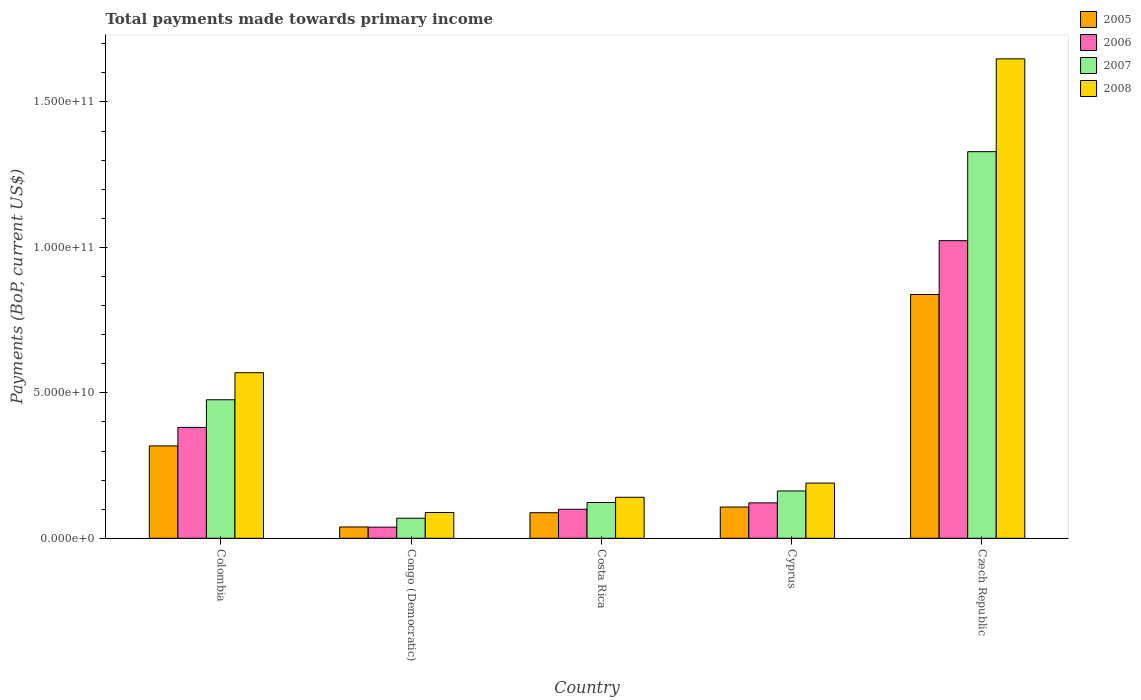How many groups of bars are there?
Offer a very short reply. 5. Are the number of bars on each tick of the X-axis equal?
Make the answer very short. Yes. How many bars are there on the 1st tick from the right?
Provide a succinct answer. 4. What is the total payments made towards primary income in 2008 in Cyprus?
Keep it short and to the point. 1.90e+1. Across all countries, what is the maximum total payments made towards primary income in 2007?
Offer a very short reply. 1.33e+11. Across all countries, what is the minimum total payments made towards primary income in 2005?
Give a very brief answer. 3.89e+09. In which country was the total payments made towards primary income in 2005 maximum?
Keep it short and to the point. Czech Republic. In which country was the total payments made towards primary income in 2007 minimum?
Your answer should be compact. Congo (Democratic). What is the total total payments made towards primary income in 2007 in the graph?
Offer a terse response. 2.16e+11. What is the difference between the total payments made towards primary income in 2005 in Colombia and that in Congo (Democratic)?
Offer a very short reply. 2.79e+1. What is the difference between the total payments made towards primary income in 2007 in Cyprus and the total payments made towards primary income in 2005 in Colombia?
Provide a succinct answer. -1.55e+1. What is the average total payments made towards primary income in 2005 per country?
Provide a succinct answer. 2.78e+1. What is the difference between the total payments made towards primary income of/in 2006 and total payments made towards primary income of/in 2005 in Czech Republic?
Provide a short and direct response. 1.85e+1. What is the ratio of the total payments made towards primary income in 2005 in Costa Rica to that in Cyprus?
Your answer should be very brief. 0.82. What is the difference between the highest and the second highest total payments made towards primary income in 2007?
Make the answer very short. -8.53e+1. What is the difference between the highest and the lowest total payments made towards primary income in 2008?
Give a very brief answer. 1.56e+11. How many bars are there?
Keep it short and to the point. 20. Are all the bars in the graph horizontal?
Give a very brief answer. No. How many countries are there in the graph?
Offer a terse response. 5. Are the values on the major ticks of Y-axis written in scientific E-notation?
Offer a very short reply. Yes. Where does the legend appear in the graph?
Provide a short and direct response. Top right. How many legend labels are there?
Make the answer very short. 4. How are the legend labels stacked?
Provide a succinct answer. Vertical. What is the title of the graph?
Your response must be concise. Total payments made towards primary income. Does "2007" appear as one of the legend labels in the graph?
Your answer should be compact. Yes. What is the label or title of the X-axis?
Your answer should be very brief. Country. What is the label or title of the Y-axis?
Offer a very short reply. Payments (BoP, current US$). What is the Payments (BoP, current US$) of 2005 in Colombia?
Provide a short and direct response. 3.18e+1. What is the Payments (BoP, current US$) of 2006 in Colombia?
Ensure brevity in your answer.  3.81e+1. What is the Payments (BoP, current US$) of 2007 in Colombia?
Offer a terse response. 4.76e+1. What is the Payments (BoP, current US$) of 2008 in Colombia?
Provide a short and direct response. 5.69e+1. What is the Payments (BoP, current US$) in 2005 in Congo (Democratic)?
Give a very brief answer. 3.89e+09. What is the Payments (BoP, current US$) of 2006 in Congo (Democratic)?
Provide a succinct answer. 3.83e+09. What is the Payments (BoP, current US$) of 2007 in Congo (Democratic)?
Your answer should be very brief. 6.90e+09. What is the Payments (BoP, current US$) in 2008 in Congo (Democratic)?
Keep it short and to the point. 8.86e+09. What is the Payments (BoP, current US$) in 2005 in Costa Rica?
Offer a terse response. 8.79e+09. What is the Payments (BoP, current US$) of 2006 in Costa Rica?
Provide a succinct answer. 9.98e+09. What is the Payments (BoP, current US$) of 2007 in Costa Rica?
Ensure brevity in your answer.  1.23e+1. What is the Payments (BoP, current US$) of 2008 in Costa Rica?
Your response must be concise. 1.41e+1. What is the Payments (BoP, current US$) in 2005 in Cyprus?
Ensure brevity in your answer.  1.07e+1. What is the Payments (BoP, current US$) of 2006 in Cyprus?
Your answer should be very brief. 1.22e+1. What is the Payments (BoP, current US$) in 2007 in Cyprus?
Keep it short and to the point. 1.63e+1. What is the Payments (BoP, current US$) of 2008 in Cyprus?
Give a very brief answer. 1.90e+1. What is the Payments (BoP, current US$) in 2005 in Czech Republic?
Offer a very short reply. 8.38e+1. What is the Payments (BoP, current US$) in 2006 in Czech Republic?
Offer a terse response. 1.02e+11. What is the Payments (BoP, current US$) of 2007 in Czech Republic?
Your response must be concise. 1.33e+11. What is the Payments (BoP, current US$) in 2008 in Czech Republic?
Your answer should be compact. 1.65e+11. Across all countries, what is the maximum Payments (BoP, current US$) of 2005?
Keep it short and to the point. 8.38e+1. Across all countries, what is the maximum Payments (BoP, current US$) of 2006?
Your answer should be compact. 1.02e+11. Across all countries, what is the maximum Payments (BoP, current US$) in 2007?
Your response must be concise. 1.33e+11. Across all countries, what is the maximum Payments (BoP, current US$) in 2008?
Give a very brief answer. 1.65e+11. Across all countries, what is the minimum Payments (BoP, current US$) of 2005?
Offer a terse response. 3.89e+09. Across all countries, what is the minimum Payments (BoP, current US$) in 2006?
Provide a succinct answer. 3.83e+09. Across all countries, what is the minimum Payments (BoP, current US$) of 2007?
Provide a short and direct response. 6.90e+09. Across all countries, what is the minimum Payments (BoP, current US$) in 2008?
Offer a very short reply. 8.86e+09. What is the total Payments (BoP, current US$) in 2005 in the graph?
Your response must be concise. 1.39e+11. What is the total Payments (BoP, current US$) in 2006 in the graph?
Offer a terse response. 1.66e+11. What is the total Payments (BoP, current US$) in 2007 in the graph?
Your response must be concise. 2.16e+11. What is the total Payments (BoP, current US$) in 2008 in the graph?
Provide a succinct answer. 2.64e+11. What is the difference between the Payments (BoP, current US$) in 2005 in Colombia and that in Congo (Democratic)?
Provide a short and direct response. 2.79e+1. What is the difference between the Payments (BoP, current US$) in 2006 in Colombia and that in Congo (Democratic)?
Ensure brevity in your answer.  3.43e+1. What is the difference between the Payments (BoP, current US$) in 2007 in Colombia and that in Congo (Democratic)?
Provide a short and direct response. 4.07e+1. What is the difference between the Payments (BoP, current US$) of 2008 in Colombia and that in Congo (Democratic)?
Ensure brevity in your answer.  4.81e+1. What is the difference between the Payments (BoP, current US$) of 2005 in Colombia and that in Costa Rica?
Keep it short and to the point. 2.30e+1. What is the difference between the Payments (BoP, current US$) in 2006 in Colombia and that in Costa Rica?
Your response must be concise. 2.81e+1. What is the difference between the Payments (BoP, current US$) in 2007 in Colombia and that in Costa Rica?
Make the answer very short. 3.53e+1. What is the difference between the Payments (BoP, current US$) of 2008 in Colombia and that in Costa Rica?
Provide a short and direct response. 4.28e+1. What is the difference between the Payments (BoP, current US$) in 2005 in Colombia and that in Cyprus?
Your answer should be very brief. 2.10e+1. What is the difference between the Payments (BoP, current US$) in 2006 in Colombia and that in Cyprus?
Provide a short and direct response. 2.59e+1. What is the difference between the Payments (BoP, current US$) of 2007 in Colombia and that in Cyprus?
Provide a succinct answer. 3.14e+1. What is the difference between the Payments (BoP, current US$) of 2008 in Colombia and that in Cyprus?
Ensure brevity in your answer.  3.80e+1. What is the difference between the Payments (BoP, current US$) of 2005 in Colombia and that in Czech Republic?
Give a very brief answer. -5.21e+1. What is the difference between the Payments (BoP, current US$) in 2006 in Colombia and that in Czech Republic?
Provide a short and direct response. -6.42e+1. What is the difference between the Payments (BoP, current US$) of 2007 in Colombia and that in Czech Republic?
Your answer should be very brief. -8.53e+1. What is the difference between the Payments (BoP, current US$) of 2008 in Colombia and that in Czech Republic?
Your response must be concise. -1.08e+11. What is the difference between the Payments (BoP, current US$) of 2005 in Congo (Democratic) and that in Costa Rica?
Make the answer very short. -4.89e+09. What is the difference between the Payments (BoP, current US$) in 2006 in Congo (Democratic) and that in Costa Rica?
Make the answer very short. -6.15e+09. What is the difference between the Payments (BoP, current US$) in 2007 in Congo (Democratic) and that in Costa Rica?
Ensure brevity in your answer.  -5.40e+09. What is the difference between the Payments (BoP, current US$) of 2008 in Congo (Democratic) and that in Costa Rica?
Offer a very short reply. -5.23e+09. What is the difference between the Payments (BoP, current US$) of 2005 in Congo (Democratic) and that in Cyprus?
Give a very brief answer. -6.85e+09. What is the difference between the Payments (BoP, current US$) of 2006 in Congo (Democratic) and that in Cyprus?
Give a very brief answer. -8.35e+09. What is the difference between the Payments (BoP, current US$) in 2007 in Congo (Democratic) and that in Cyprus?
Offer a very short reply. -9.37e+09. What is the difference between the Payments (BoP, current US$) of 2008 in Congo (Democratic) and that in Cyprus?
Give a very brief answer. -1.01e+1. What is the difference between the Payments (BoP, current US$) in 2005 in Congo (Democratic) and that in Czech Republic?
Your response must be concise. -7.99e+1. What is the difference between the Payments (BoP, current US$) in 2006 in Congo (Democratic) and that in Czech Republic?
Keep it short and to the point. -9.85e+1. What is the difference between the Payments (BoP, current US$) of 2007 in Congo (Democratic) and that in Czech Republic?
Provide a short and direct response. -1.26e+11. What is the difference between the Payments (BoP, current US$) of 2008 in Congo (Democratic) and that in Czech Republic?
Make the answer very short. -1.56e+11. What is the difference between the Payments (BoP, current US$) in 2005 in Costa Rica and that in Cyprus?
Offer a terse response. -1.96e+09. What is the difference between the Payments (BoP, current US$) in 2006 in Costa Rica and that in Cyprus?
Your answer should be very brief. -2.20e+09. What is the difference between the Payments (BoP, current US$) in 2007 in Costa Rica and that in Cyprus?
Your answer should be compact. -3.97e+09. What is the difference between the Payments (BoP, current US$) of 2008 in Costa Rica and that in Cyprus?
Offer a terse response. -4.88e+09. What is the difference between the Payments (BoP, current US$) of 2005 in Costa Rica and that in Czech Republic?
Keep it short and to the point. -7.50e+1. What is the difference between the Payments (BoP, current US$) of 2006 in Costa Rica and that in Czech Republic?
Your answer should be compact. -9.23e+1. What is the difference between the Payments (BoP, current US$) of 2007 in Costa Rica and that in Czech Republic?
Provide a succinct answer. -1.21e+11. What is the difference between the Payments (BoP, current US$) of 2008 in Costa Rica and that in Czech Republic?
Offer a terse response. -1.51e+11. What is the difference between the Payments (BoP, current US$) of 2005 in Cyprus and that in Czech Republic?
Your answer should be compact. -7.31e+1. What is the difference between the Payments (BoP, current US$) in 2006 in Cyprus and that in Czech Republic?
Keep it short and to the point. -9.01e+1. What is the difference between the Payments (BoP, current US$) of 2007 in Cyprus and that in Czech Republic?
Make the answer very short. -1.17e+11. What is the difference between the Payments (BoP, current US$) of 2008 in Cyprus and that in Czech Republic?
Provide a succinct answer. -1.46e+11. What is the difference between the Payments (BoP, current US$) of 2005 in Colombia and the Payments (BoP, current US$) of 2006 in Congo (Democratic)?
Make the answer very short. 2.79e+1. What is the difference between the Payments (BoP, current US$) of 2005 in Colombia and the Payments (BoP, current US$) of 2007 in Congo (Democratic)?
Your response must be concise. 2.49e+1. What is the difference between the Payments (BoP, current US$) of 2005 in Colombia and the Payments (BoP, current US$) of 2008 in Congo (Democratic)?
Make the answer very short. 2.29e+1. What is the difference between the Payments (BoP, current US$) of 2006 in Colombia and the Payments (BoP, current US$) of 2007 in Congo (Democratic)?
Provide a succinct answer. 3.12e+1. What is the difference between the Payments (BoP, current US$) in 2006 in Colombia and the Payments (BoP, current US$) in 2008 in Congo (Democratic)?
Your response must be concise. 2.93e+1. What is the difference between the Payments (BoP, current US$) in 2007 in Colombia and the Payments (BoP, current US$) in 2008 in Congo (Democratic)?
Give a very brief answer. 3.88e+1. What is the difference between the Payments (BoP, current US$) in 2005 in Colombia and the Payments (BoP, current US$) in 2006 in Costa Rica?
Make the answer very short. 2.18e+1. What is the difference between the Payments (BoP, current US$) of 2005 in Colombia and the Payments (BoP, current US$) of 2007 in Costa Rica?
Make the answer very short. 1.95e+1. What is the difference between the Payments (BoP, current US$) in 2005 in Colombia and the Payments (BoP, current US$) in 2008 in Costa Rica?
Provide a short and direct response. 1.77e+1. What is the difference between the Payments (BoP, current US$) in 2006 in Colombia and the Payments (BoP, current US$) in 2007 in Costa Rica?
Ensure brevity in your answer.  2.58e+1. What is the difference between the Payments (BoP, current US$) in 2006 in Colombia and the Payments (BoP, current US$) in 2008 in Costa Rica?
Your response must be concise. 2.40e+1. What is the difference between the Payments (BoP, current US$) in 2007 in Colombia and the Payments (BoP, current US$) in 2008 in Costa Rica?
Keep it short and to the point. 3.35e+1. What is the difference between the Payments (BoP, current US$) in 2005 in Colombia and the Payments (BoP, current US$) in 2006 in Cyprus?
Provide a short and direct response. 1.96e+1. What is the difference between the Payments (BoP, current US$) in 2005 in Colombia and the Payments (BoP, current US$) in 2007 in Cyprus?
Make the answer very short. 1.55e+1. What is the difference between the Payments (BoP, current US$) in 2005 in Colombia and the Payments (BoP, current US$) in 2008 in Cyprus?
Your response must be concise. 1.28e+1. What is the difference between the Payments (BoP, current US$) in 2006 in Colombia and the Payments (BoP, current US$) in 2007 in Cyprus?
Offer a very short reply. 2.19e+1. What is the difference between the Payments (BoP, current US$) of 2006 in Colombia and the Payments (BoP, current US$) of 2008 in Cyprus?
Your answer should be very brief. 1.91e+1. What is the difference between the Payments (BoP, current US$) in 2007 in Colombia and the Payments (BoP, current US$) in 2008 in Cyprus?
Your answer should be compact. 2.87e+1. What is the difference between the Payments (BoP, current US$) in 2005 in Colombia and the Payments (BoP, current US$) in 2006 in Czech Republic?
Give a very brief answer. -7.06e+1. What is the difference between the Payments (BoP, current US$) in 2005 in Colombia and the Payments (BoP, current US$) in 2007 in Czech Republic?
Give a very brief answer. -1.01e+11. What is the difference between the Payments (BoP, current US$) of 2005 in Colombia and the Payments (BoP, current US$) of 2008 in Czech Republic?
Provide a succinct answer. -1.33e+11. What is the difference between the Payments (BoP, current US$) in 2006 in Colombia and the Payments (BoP, current US$) in 2007 in Czech Republic?
Your answer should be very brief. -9.48e+1. What is the difference between the Payments (BoP, current US$) in 2006 in Colombia and the Payments (BoP, current US$) in 2008 in Czech Republic?
Provide a succinct answer. -1.27e+11. What is the difference between the Payments (BoP, current US$) of 2007 in Colombia and the Payments (BoP, current US$) of 2008 in Czech Republic?
Offer a very short reply. -1.17e+11. What is the difference between the Payments (BoP, current US$) in 2005 in Congo (Democratic) and the Payments (BoP, current US$) in 2006 in Costa Rica?
Make the answer very short. -6.08e+09. What is the difference between the Payments (BoP, current US$) of 2005 in Congo (Democratic) and the Payments (BoP, current US$) of 2007 in Costa Rica?
Give a very brief answer. -8.41e+09. What is the difference between the Payments (BoP, current US$) in 2005 in Congo (Democratic) and the Payments (BoP, current US$) in 2008 in Costa Rica?
Keep it short and to the point. -1.02e+1. What is the difference between the Payments (BoP, current US$) of 2006 in Congo (Democratic) and the Payments (BoP, current US$) of 2007 in Costa Rica?
Your answer should be compact. -8.47e+09. What is the difference between the Payments (BoP, current US$) in 2006 in Congo (Democratic) and the Payments (BoP, current US$) in 2008 in Costa Rica?
Provide a succinct answer. -1.03e+1. What is the difference between the Payments (BoP, current US$) in 2007 in Congo (Democratic) and the Payments (BoP, current US$) in 2008 in Costa Rica?
Give a very brief answer. -7.19e+09. What is the difference between the Payments (BoP, current US$) of 2005 in Congo (Democratic) and the Payments (BoP, current US$) of 2006 in Cyprus?
Your answer should be compact. -8.29e+09. What is the difference between the Payments (BoP, current US$) in 2005 in Congo (Democratic) and the Payments (BoP, current US$) in 2007 in Cyprus?
Your answer should be very brief. -1.24e+1. What is the difference between the Payments (BoP, current US$) of 2005 in Congo (Democratic) and the Payments (BoP, current US$) of 2008 in Cyprus?
Offer a very short reply. -1.51e+1. What is the difference between the Payments (BoP, current US$) of 2006 in Congo (Democratic) and the Payments (BoP, current US$) of 2007 in Cyprus?
Keep it short and to the point. -1.24e+1. What is the difference between the Payments (BoP, current US$) of 2006 in Congo (Democratic) and the Payments (BoP, current US$) of 2008 in Cyprus?
Make the answer very short. -1.51e+1. What is the difference between the Payments (BoP, current US$) in 2007 in Congo (Democratic) and the Payments (BoP, current US$) in 2008 in Cyprus?
Offer a very short reply. -1.21e+1. What is the difference between the Payments (BoP, current US$) of 2005 in Congo (Democratic) and the Payments (BoP, current US$) of 2006 in Czech Republic?
Offer a very short reply. -9.84e+1. What is the difference between the Payments (BoP, current US$) of 2005 in Congo (Democratic) and the Payments (BoP, current US$) of 2007 in Czech Republic?
Give a very brief answer. -1.29e+11. What is the difference between the Payments (BoP, current US$) of 2005 in Congo (Democratic) and the Payments (BoP, current US$) of 2008 in Czech Republic?
Your answer should be very brief. -1.61e+11. What is the difference between the Payments (BoP, current US$) in 2006 in Congo (Democratic) and the Payments (BoP, current US$) in 2007 in Czech Republic?
Your answer should be compact. -1.29e+11. What is the difference between the Payments (BoP, current US$) of 2006 in Congo (Democratic) and the Payments (BoP, current US$) of 2008 in Czech Republic?
Your answer should be very brief. -1.61e+11. What is the difference between the Payments (BoP, current US$) in 2007 in Congo (Democratic) and the Payments (BoP, current US$) in 2008 in Czech Republic?
Provide a succinct answer. -1.58e+11. What is the difference between the Payments (BoP, current US$) of 2005 in Costa Rica and the Payments (BoP, current US$) of 2006 in Cyprus?
Provide a succinct answer. -3.39e+09. What is the difference between the Payments (BoP, current US$) in 2005 in Costa Rica and the Payments (BoP, current US$) in 2007 in Cyprus?
Make the answer very short. -7.48e+09. What is the difference between the Payments (BoP, current US$) of 2005 in Costa Rica and the Payments (BoP, current US$) of 2008 in Cyprus?
Keep it short and to the point. -1.02e+1. What is the difference between the Payments (BoP, current US$) in 2006 in Costa Rica and the Payments (BoP, current US$) in 2007 in Cyprus?
Make the answer very short. -6.29e+09. What is the difference between the Payments (BoP, current US$) in 2006 in Costa Rica and the Payments (BoP, current US$) in 2008 in Cyprus?
Give a very brief answer. -8.99e+09. What is the difference between the Payments (BoP, current US$) of 2007 in Costa Rica and the Payments (BoP, current US$) of 2008 in Cyprus?
Keep it short and to the point. -6.67e+09. What is the difference between the Payments (BoP, current US$) of 2005 in Costa Rica and the Payments (BoP, current US$) of 2006 in Czech Republic?
Offer a very short reply. -9.35e+1. What is the difference between the Payments (BoP, current US$) of 2005 in Costa Rica and the Payments (BoP, current US$) of 2007 in Czech Republic?
Offer a very short reply. -1.24e+11. What is the difference between the Payments (BoP, current US$) in 2005 in Costa Rica and the Payments (BoP, current US$) in 2008 in Czech Republic?
Make the answer very short. -1.56e+11. What is the difference between the Payments (BoP, current US$) in 2006 in Costa Rica and the Payments (BoP, current US$) in 2007 in Czech Republic?
Provide a short and direct response. -1.23e+11. What is the difference between the Payments (BoP, current US$) of 2006 in Costa Rica and the Payments (BoP, current US$) of 2008 in Czech Republic?
Your answer should be compact. -1.55e+11. What is the difference between the Payments (BoP, current US$) of 2007 in Costa Rica and the Payments (BoP, current US$) of 2008 in Czech Republic?
Offer a very short reply. -1.53e+11. What is the difference between the Payments (BoP, current US$) in 2005 in Cyprus and the Payments (BoP, current US$) in 2006 in Czech Republic?
Make the answer very short. -9.16e+1. What is the difference between the Payments (BoP, current US$) in 2005 in Cyprus and the Payments (BoP, current US$) in 2007 in Czech Republic?
Your response must be concise. -1.22e+11. What is the difference between the Payments (BoP, current US$) of 2005 in Cyprus and the Payments (BoP, current US$) of 2008 in Czech Republic?
Keep it short and to the point. -1.54e+11. What is the difference between the Payments (BoP, current US$) of 2006 in Cyprus and the Payments (BoP, current US$) of 2007 in Czech Republic?
Ensure brevity in your answer.  -1.21e+11. What is the difference between the Payments (BoP, current US$) of 2006 in Cyprus and the Payments (BoP, current US$) of 2008 in Czech Republic?
Your answer should be very brief. -1.53e+11. What is the difference between the Payments (BoP, current US$) of 2007 in Cyprus and the Payments (BoP, current US$) of 2008 in Czech Republic?
Keep it short and to the point. -1.49e+11. What is the average Payments (BoP, current US$) in 2005 per country?
Make the answer very short. 2.78e+1. What is the average Payments (BoP, current US$) in 2006 per country?
Your answer should be compact. 3.33e+1. What is the average Payments (BoP, current US$) in 2007 per country?
Provide a short and direct response. 4.32e+1. What is the average Payments (BoP, current US$) in 2008 per country?
Offer a very short reply. 5.27e+1. What is the difference between the Payments (BoP, current US$) of 2005 and Payments (BoP, current US$) of 2006 in Colombia?
Your answer should be very brief. -6.36e+09. What is the difference between the Payments (BoP, current US$) in 2005 and Payments (BoP, current US$) in 2007 in Colombia?
Ensure brevity in your answer.  -1.59e+1. What is the difference between the Payments (BoP, current US$) in 2005 and Payments (BoP, current US$) in 2008 in Colombia?
Make the answer very short. -2.52e+1. What is the difference between the Payments (BoP, current US$) in 2006 and Payments (BoP, current US$) in 2007 in Colombia?
Offer a very short reply. -9.51e+09. What is the difference between the Payments (BoP, current US$) of 2006 and Payments (BoP, current US$) of 2008 in Colombia?
Provide a short and direct response. -1.88e+1. What is the difference between the Payments (BoP, current US$) in 2007 and Payments (BoP, current US$) in 2008 in Colombia?
Offer a very short reply. -9.30e+09. What is the difference between the Payments (BoP, current US$) in 2005 and Payments (BoP, current US$) in 2006 in Congo (Democratic)?
Keep it short and to the point. 6.30e+07. What is the difference between the Payments (BoP, current US$) of 2005 and Payments (BoP, current US$) of 2007 in Congo (Democratic)?
Provide a short and direct response. -3.01e+09. What is the difference between the Payments (BoP, current US$) of 2005 and Payments (BoP, current US$) of 2008 in Congo (Democratic)?
Your response must be concise. -4.97e+09. What is the difference between the Payments (BoP, current US$) in 2006 and Payments (BoP, current US$) in 2007 in Congo (Democratic)?
Make the answer very short. -3.07e+09. What is the difference between the Payments (BoP, current US$) of 2006 and Payments (BoP, current US$) of 2008 in Congo (Democratic)?
Your response must be concise. -5.03e+09. What is the difference between the Payments (BoP, current US$) of 2007 and Payments (BoP, current US$) of 2008 in Congo (Democratic)?
Offer a very short reply. -1.96e+09. What is the difference between the Payments (BoP, current US$) in 2005 and Payments (BoP, current US$) in 2006 in Costa Rica?
Your answer should be very brief. -1.19e+09. What is the difference between the Payments (BoP, current US$) in 2005 and Payments (BoP, current US$) in 2007 in Costa Rica?
Your answer should be compact. -3.51e+09. What is the difference between the Payments (BoP, current US$) in 2005 and Payments (BoP, current US$) in 2008 in Costa Rica?
Your response must be concise. -5.31e+09. What is the difference between the Payments (BoP, current US$) of 2006 and Payments (BoP, current US$) of 2007 in Costa Rica?
Provide a short and direct response. -2.32e+09. What is the difference between the Payments (BoP, current US$) in 2006 and Payments (BoP, current US$) in 2008 in Costa Rica?
Give a very brief answer. -4.12e+09. What is the difference between the Payments (BoP, current US$) of 2007 and Payments (BoP, current US$) of 2008 in Costa Rica?
Your answer should be compact. -1.79e+09. What is the difference between the Payments (BoP, current US$) of 2005 and Payments (BoP, current US$) of 2006 in Cyprus?
Make the answer very short. -1.43e+09. What is the difference between the Payments (BoP, current US$) in 2005 and Payments (BoP, current US$) in 2007 in Cyprus?
Keep it short and to the point. -5.52e+09. What is the difference between the Payments (BoP, current US$) of 2005 and Payments (BoP, current US$) of 2008 in Cyprus?
Provide a succinct answer. -8.22e+09. What is the difference between the Payments (BoP, current US$) in 2006 and Payments (BoP, current US$) in 2007 in Cyprus?
Offer a terse response. -4.09e+09. What is the difference between the Payments (BoP, current US$) in 2006 and Payments (BoP, current US$) in 2008 in Cyprus?
Give a very brief answer. -6.79e+09. What is the difference between the Payments (BoP, current US$) of 2007 and Payments (BoP, current US$) of 2008 in Cyprus?
Provide a short and direct response. -2.70e+09. What is the difference between the Payments (BoP, current US$) in 2005 and Payments (BoP, current US$) in 2006 in Czech Republic?
Offer a terse response. -1.85e+1. What is the difference between the Payments (BoP, current US$) of 2005 and Payments (BoP, current US$) of 2007 in Czech Republic?
Offer a terse response. -4.91e+1. What is the difference between the Payments (BoP, current US$) in 2005 and Payments (BoP, current US$) in 2008 in Czech Republic?
Provide a succinct answer. -8.10e+1. What is the difference between the Payments (BoP, current US$) of 2006 and Payments (BoP, current US$) of 2007 in Czech Republic?
Keep it short and to the point. -3.06e+1. What is the difference between the Payments (BoP, current US$) in 2006 and Payments (BoP, current US$) in 2008 in Czech Republic?
Your answer should be compact. -6.25e+1. What is the difference between the Payments (BoP, current US$) of 2007 and Payments (BoP, current US$) of 2008 in Czech Republic?
Your response must be concise. -3.19e+1. What is the ratio of the Payments (BoP, current US$) of 2005 in Colombia to that in Congo (Democratic)?
Your answer should be very brief. 8.16. What is the ratio of the Payments (BoP, current US$) in 2006 in Colombia to that in Congo (Democratic)?
Keep it short and to the point. 9.96. What is the ratio of the Payments (BoP, current US$) of 2007 in Colombia to that in Congo (Democratic)?
Provide a short and direct response. 6.9. What is the ratio of the Payments (BoP, current US$) of 2008 in Colombia to that in Congo (Democratic)?
Your response must be concise. 6.42. What is the ratio of the Payments (BoP, current US$) in 2005 in Colombia to that in Costa Rica?
Ensure brevity in your answer.  3.61. What is the ratio of the Payments (BoP, current US$) of 2006 in Colombia to that in Costa Rica?
Provide a short and direct response. 3.82. What is the ratio of the Payments (BoP, current US$) in 2007 in Colombia to that in Costa Rica?
Your response must be concise. 3.87. What is the ratio of the Payments (BoP, current US$) in 2008 in Colombia to that in Costa Rica?
Offer a very short reply. 4.04. What is the ratio of the Payments (BoP, current US$) in 2005 in Colombia to that in Cyprus?
Offer a terse response. 2.96. What is the ratio of the Payments (BoP, current US$) of 2006 in Colombia to that in Cyprus?
Provide a succinct answer. 3.13. What is the ratio of the Payments (BoP, current US$) in 2007 in Colombia to that in Cyprus?
Make the answer very short. 2.93. What is the ratio of the Payments (BoP, current US$) of 2008 in Colombia to that in Cyprus?
Give a very brief answer. 3. What is the ratio of the Payments (BoP, current US$) in 2005 in Colombia to that in Czech Republic?
Your answer should be compact. 0.38. What is the ratio of the Payments (BoP, current US$) in 2006 in Colombia to that in Czech Republic?
Provide a short and direct response. 0.37. What is the ratio of the Payments (BoP, current US$) of 2007 in Colombia to that in Czech Republic?
Offer a very short reply. 0.36. What is the ratio of the Payments (BoP, current US$) in 2008 in Colombia to that in Czech Republic?
Provide a succinct answer. 0.35. What is the ratio of the Payments (BoP, current US$) of 2005 in Congo (Democratic) to that in Costa Rica?
Offer a terse response. 0.44. What is the ratio of the Payments (BoP, current US$) of 2006 in Congo (Democratic) to that in Costa Rica?
Make the answer very short. 0.38. What is the ratio of the Payments (BoP, current US$) of 2007 in Congo (Democratic) to that in Costa Rica?
Provide a short and direct response. 0.56. What is the ratio of the Payments (BoP, current US$) in 2008 in Congo (Democratic) to that in Costa Rica?
Make the answer very short. 0.63. What is the ratio of the Payments (BoP, current US$) of 2005 in Congo (Democratic) to that in Cyprus?
Offer a very short reply. 0.36. What is the ratio of the Payments (BoP, current US$) of 2006 in Congo (Democratic) to that in Cyprus?
Provide a succinct answer. 0.31. What is the ratio of the Payments (BoP, current US$) in 2007 in Congo (Democratic) to that in Cyprus?
Make the answer very short. 0.42. What is the ratio of the Payments (BoP, current US$) in 2008 in Congo (Democratic) to that in Cyprus?
Your answer should be very brief. 0.47. What is the ratio of the Payments (BoP, current US$) in 2005 in Congo (Democratic) to that in Czech Republic?
Your response must be concise. 0.05. What is the ratio of the Payments (BoP, current US$) in 2006 in Congo (Democratic) to that in Czech Republic?
Your answer should be compact. 0.04. What is the ratio of the Payments (BoP, current US$) of 2007 in Congo (Democratic) to that in Czech Republic?
Ensure brevity in your answer.  0.05. What is the ratio of the Payments (BoP, current US$) of 2008 in Congo (Democratic) to that in Czech Republic?
Ensure brevity in your answer.  0.05. What is the ratio of the Payments (BoP, current US$) of 2005 in Costa Rica to that in Cyprus?
Give a very brief answer. 0.82. What is the ratio of the Payments (BoP, current US$) of 2006 in Costa Rica to that in Cyprus?
Offer a terse response. 0.82. What is the ratio of the Payments (BoP, current US$) in 2007 in Costa Rica to that in Cyprus?
Offer a very short reply. 0.76. What is the ratio of the Payments (BoP, current US$) in 2008 in Costa Rica to that in Cyprus?
Your answer should be compact. 0.74. What is the ratio of the Payments (BoP, current US$) of 2005 in Costa Rica to that in Czech Republic?
Offer a very short reply. 0.1. What is the ratio of the Payments (BoP, current US$) in 2006 in Costa Rica to that in Czech Republic?
Provide a succinct answer. 0.1. What is the ratio of the Payments (BoP, current US$) of 2007 in Costa Rica to that in Czech Republic?
Your answer should be very brief. 0.09. What is the ratio of the Payments (BoP, current US$) in 2008 in Costa Rica to that in Czech Republic?
Your answer should be compact. 0.09. What is the ratio of the Payments (BoP, current US$) of 2005 in Cyprus to that in Czech Republic?
Give a very brief answer. 0.13. What is the ratio of the Payments (BoP, current US$) of 2006 in Cyprus to that in Czech Republic?
Provide a short and direct response. 0.12. What is the ratio of the Payments (BoP, current US$) of 2007 in Cyprus to that in Czech Republic?
Offer a very short reply. 0.12. What is the ratio of the Payments (BoP, current US$) of 2008 in Cyprus to that in Czech Republic?
Provide a succinct answer. 0.12. What is the difference between the highest and the second highest Payments (BoP, current US$) of 2005?
Your answer should be very brief. 5.21e+1. What is the difference between the highest and the second highest Payments (BoP, current US$) in 2006?
Give a very brief answer. 6.42e+1. What is the difference between the highest and the second highest Payments (BoP, current US$) in 2007?
Offer a terse response. 8.53e+1. What is the difference between the highest and the second highest Payments (BoP, current US$) in 2008?
Keep it short and to the point. 1.08e+11. What is the difference between the highest and the lowest Payments (BoP, current US$) in 2005?
Keep it short and to the point. 7.99e+1. What is the difference between the highest and the lowest Payments (BoP, current US$) of 2006?
Keep it short and to the point. 9.85e+1. What is the difference between the highest and the lowest Payments (BoP, current US$) of 2007?
Offer a terse response. 1.26e+11. What is the difference between the highest and the lowest Payments (BoP, current US$) of 2008?
Give a very brief answer. 1.56e+11. 